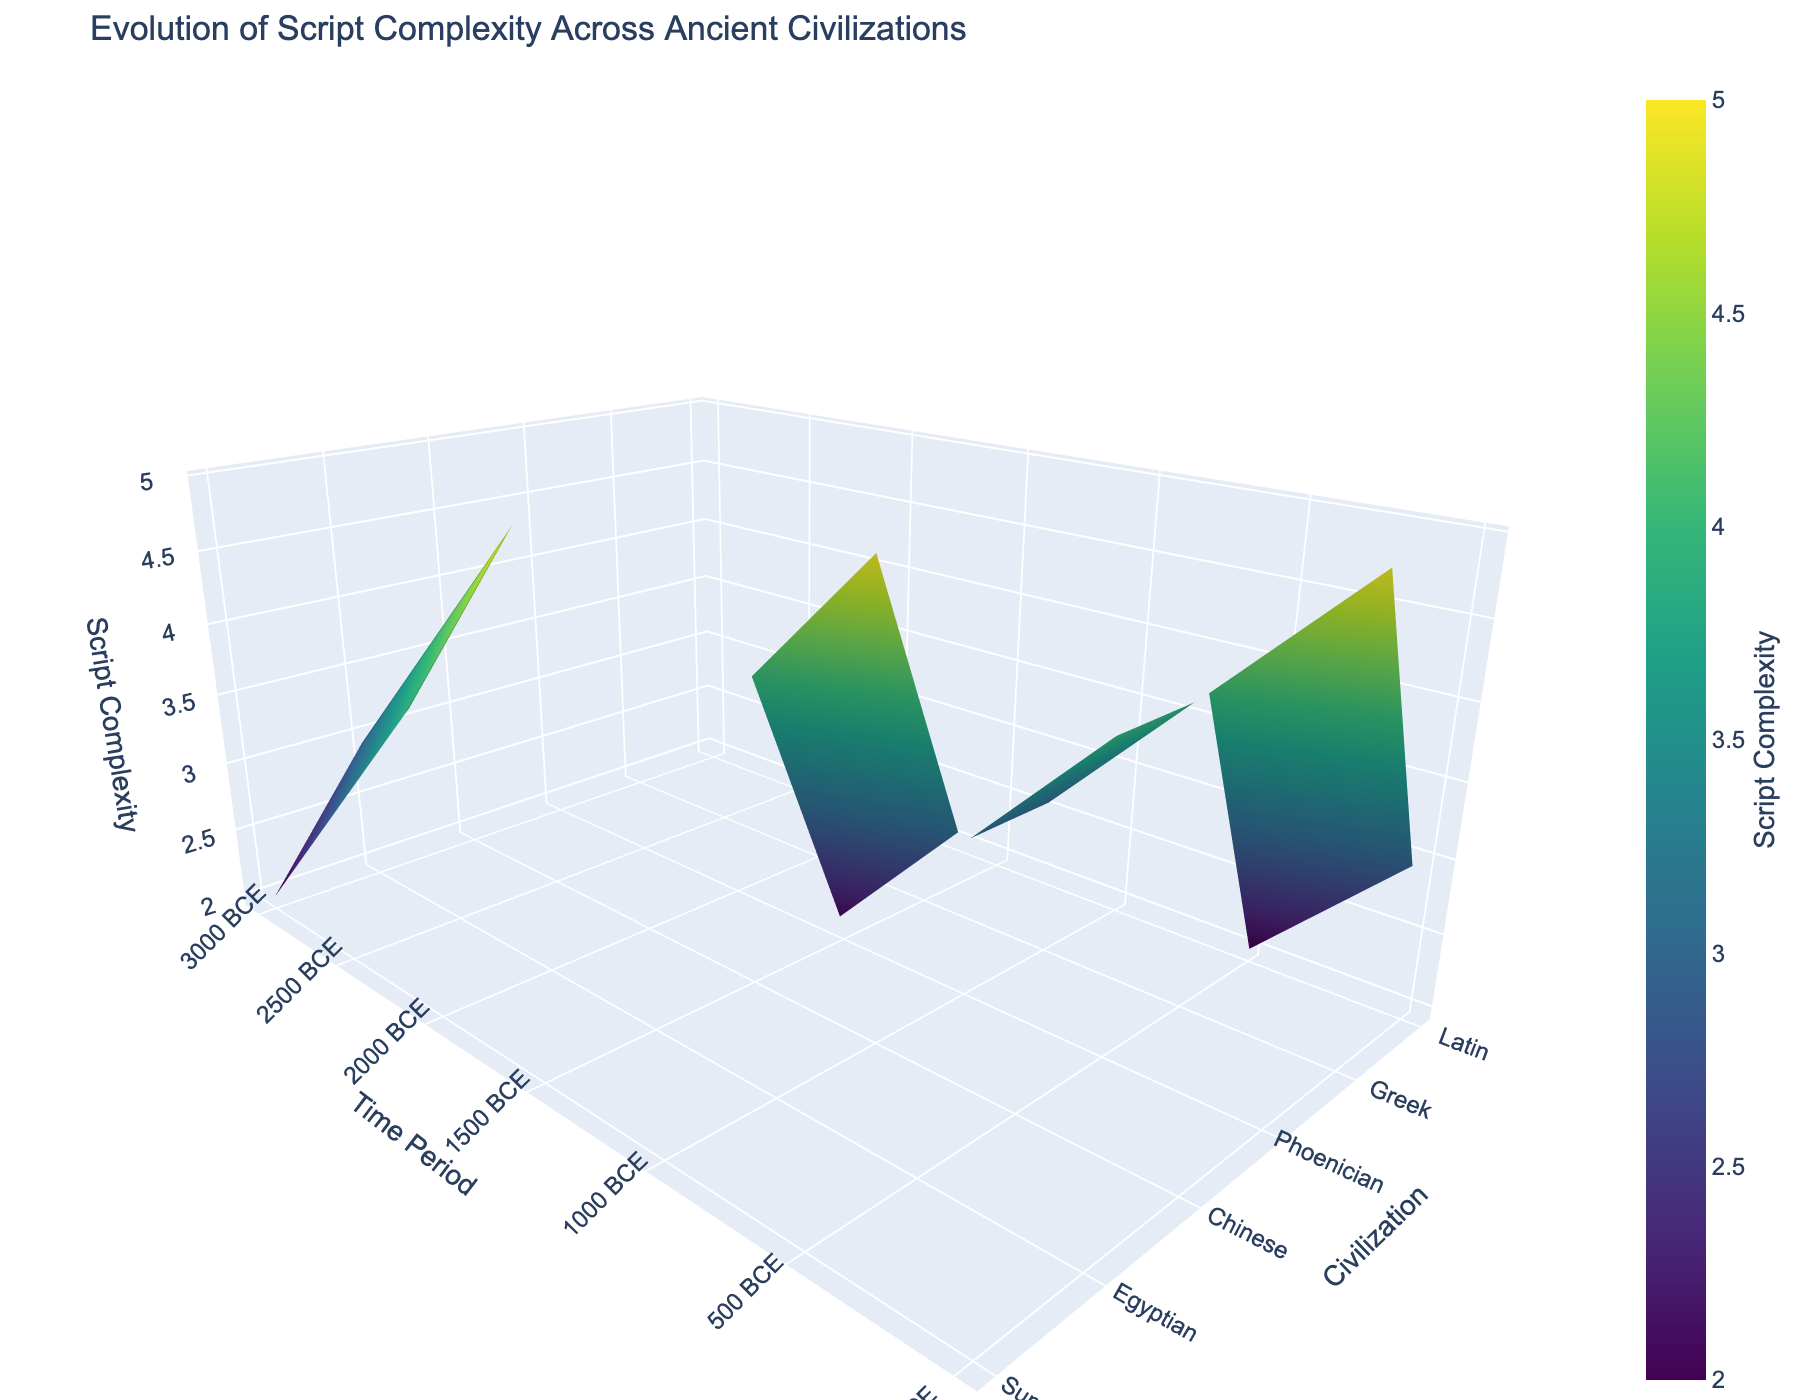What is the title of the plot? The title of the plot is displayed at the top of the figure. Reading it directly, we see that it is "Evolution of Script Complexity Across Ancient Civilizations."
Answer: Evolution of Script Complexity Across Ancient Civilizations Which civilization has the highest script complexity around 0 CE? Looking at the figure, we see that the civilization with the highest script complexity around 0 CE is Greek with a complexity of 5.
Answer: Greek How does script complexity for the Sumerian civilization change over the observed periods? Examining the Sumerian civilization on the 3D surface plot, we see that the script complexity starts at 2 in 3000 BCE, increases to 3 in 2500 BCE, and then to 4 in 2000 BCE.
Answer: Increases By how much did the script complexity of the Latin civilization increase from 500 BCE to 500 CE? Observing the Latin civilization on the 3D surface plot, we notice that the script complexity grows from 2 in 500 BCE to 4 in 500 CE. The increase is calculated as 4 - 2.
Answer: 2 Which civilization shows the least change in script complexity over time? Analyzing the various civilizations, Phoenician undergoes the least change: it starts at 2 in 1500 BCE and ends at 4 in 500 BCE, an increase of just 2 units over 1000 years.
Answer: Phoenician Is there a period where the Chinese civilization has the same script complexity as the Greek civilization? If so, what is it? We can see that around 1000 BCE, both the Chinese and the Greek civilizations have a script complexity of 3, as indicated by the same height in the plot.
Answer: 1000 BCE Which civilization had the highest script complexity in 2000 BCE? Referring to the 3D surface plot, it shows that in 2000 BCE, the Egyptian civilization had the highest script complexity with a value of 5.
Answer: Egyptian Compare the script complexities between Greek and Latin civilizations around 0 CE. Observing the data points around 0 CE, the Greek civilization has a script complexity of 5, while the Latin civilization has a complexity of 3. Hence, Greek's complexity is higher by 2.
Answer: Greek's complexity is higher by 2 Does the Egyptian civilization have a higher script complexity than the Sumerian civilization at any given point in time? By comparing the heights of the plots for both civilizations at overlapping periods, we notice that the Egyptian complexity (3 to 5) is always at least equal to or higher than the Sumerian complexity (2 to 4) in the same periods.
Answer: Yes How does the height of the script complexity surface for Phoenician in 1500 BCE compare to that of the Latin civilization in 0 CE? Observing the heights in the 3D surface plot, we see that Phoenician's script complexity in 1500 BCE is 2, whereas Latin's in 0 CE is 3, making Latin’s greater by 1 unit.
Answer: Latin’s is greater by 1 